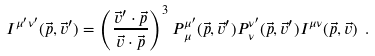<formula> <loc_0><loc_0><loc_500><loc_500>I ^ { \mu ^ { \prime } \nu ^ { \prime } } ( \vec { p } , \vec { v } ^ { \prime } ) = \left ( \frac { \vec { v } ^ { \prime } \cdot \vec { p } } { \vec { v } \cdot \vec { p } } \right ) ^ { 3 } P ^ { \mu ^ { \prime } } _ { \, \mu } ( \vec { p } , \vec { v } ^ { \prime } ) P ^ { \nu ^ { \prime } } _ { \, \nu } ( \vec { p } , \vec { v } ^ { \prime } ) I ^ { \mu \nu } ( \vec { p } , \vec { v } ) \ .</formula> 